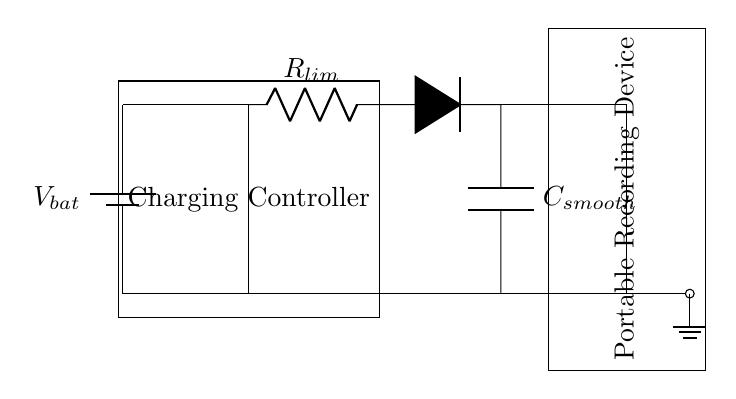What is the main component used for charging? The main component for charging in this circuit is the Charging Controller, which regulates the charge coming from the battery to the portable recording device.
Answer: Charging Controller What does R_lim do in this circuit? R_lim is a current limiting resistor that prevents excessive current from reaching the portable recording device and protects it from damage while charging.
Answer: Current limiting What type of device is represented in the circuit? The circuit indicates a portable recording device, which is the load that gets powered by the charging circuit.
Answer: Portable recording device What is the purpose of the diode in this circuit? The diode provides reverse polarity protection, ensuring that current only flows in the intended direction and preventing damage if the battery is connected incorrectly.
Answer: Reverse polarity protection What is the role of the capacitor in the circuit? The capacitor smooths out the voltage fluctuations from the charging process, providing a stable voltage to the portable recording device and improving overall performance.
Answer: Smoothing voltage How many main sections are present in this circuit? The circuit consists of three main sections: the battery section, the charging controller section, and the load section (portable recording device).
Answer: Three main sections What does the battery symbol represent in this diagram? The battery symbol represents a power source providing the necessary voltage to the circuit in order to charge the portable recording device.
Answer: Power source 